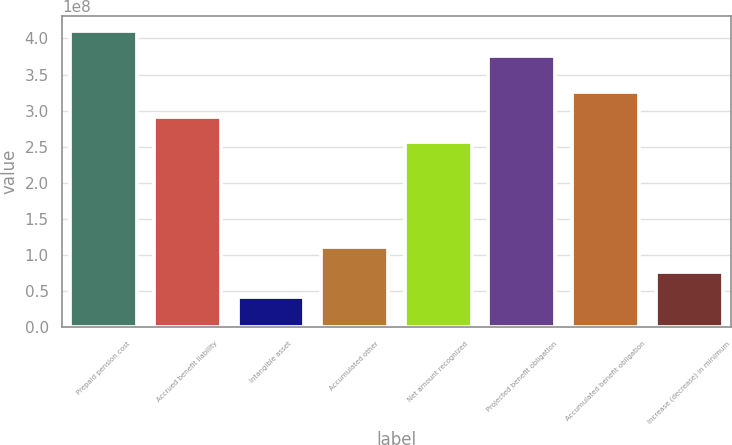<chart> <loc_0><loc_0><loc_500><loc_500><bar_chart><fcel>Prepaid pension cost<fcel>Accrued benefit liability<fcel>Intangible asset<fcel>Accumulated other<fcel>Net amount recognized<fcel>Projected benefit obligation<fcel>Accumulated benefit obligation<fcel>Increase (decrease) in minimum<nl><fcel>4.10244e+08<fcel>2.90876e+08<fcel>4.224e+07<fcel>1.11745e+08<fcel>2.56123e+08<fcel>3.75491e+08<fcel>3.25628e+08<fcel>7.69926e+07<nl></chart> 